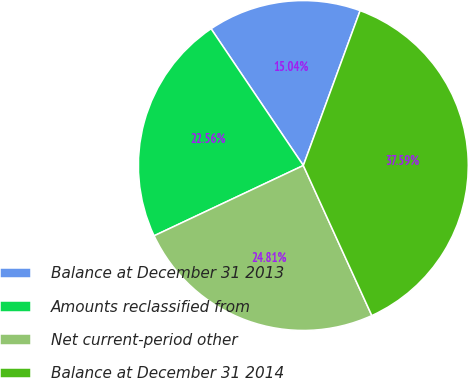Convert chart. <chart><loc_0><loc_0><loc_500><loc_500><pie_chart><fcel>Balance at December 31 2013<fcel>Amounts reclassified from<fcel>Net current-period other<fcel>Balance at December 31 2014<nl><fcel>15.04%<fcel>22.56%<fcel>24.81%<fcel>37.59%<nl></chart> 